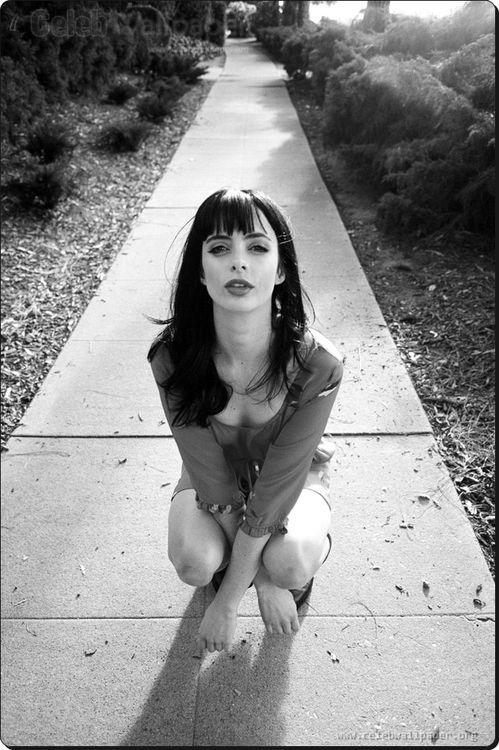What do you think is going on in this snapshot? The image captures a woman kneelings on a sidewalk, offering a compelling portrait of stillness and intensity. She is dressed in a light-colored blouse and dark pants, the contrast emphasizing her striking pose against the simple urban background of sidewalk and shrubbery. Her hair styled with bangs and a direct, serious gaze towards the camera adds to the overall dramatic effect. This scene might suggest a moment of contemplation or a staged shot intended to capture a mood of introspective determination. 